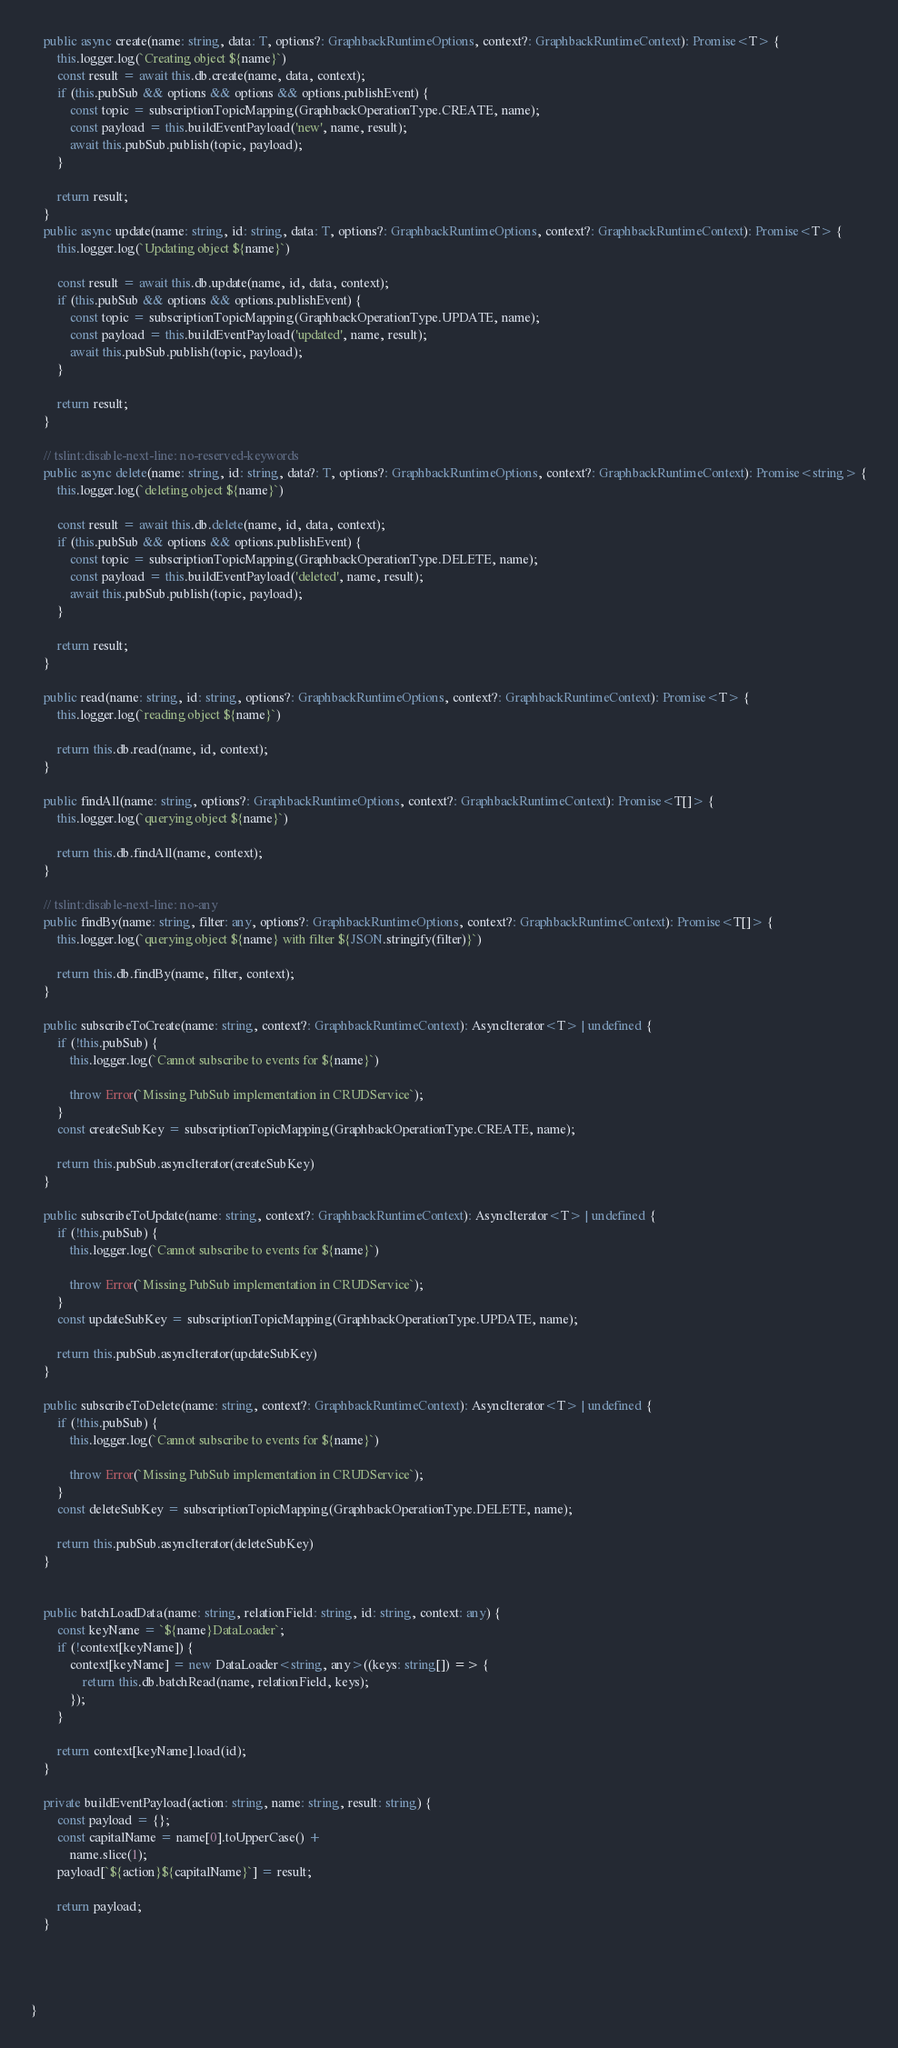<code> <loc_0><loc_0><loc_500><loc_500><_TypeScript_>    public async create(name: string, data: T, options?: GraphbackRuntimeOptions, context?: GraphbackRuntimeContext): Promise<T> {
        this.logger.log(`Creating object ${name}`)
        const result = await this.db.create(name, data, context);
        if (this.pubSub && options && options && options.publishEvent) {
            const topic = subscriptionTopicMapping(GraphbackOperationType.CREATE, name);
            const payload = this.buildEventPayload('new', name, result);
            await this.pubSub.publish(topic, payload);
        }

        return result;
    }
    public async update(name: string, id: string, data: T, options?: GraphbackRuntimeOptions, context?: GraphbackRuntimeContext): Promise<T> {
        this.logger.log(`Updating object ${name}`)

        const result = await this.db.update(name, id, data, context);
        if (this.pubSub && options && options.publishEvent) {
            const topic = subscriptionTopicMapping(GraphbackOperationType.UPDATE, name);
            const payload = this.buildEventPayload('updated', name, result);
            await this.pubSub.publish(topic, payload);
        }

        return result;
    }

    // tslint:disable-next-line: no-reserved-keywords
    public async delete(name: string, id: string, data?: T, options?: GraphbackRuntimeOptions, context?: GraphbackRuntimeContext): Promise<string> {
        this.logger.log(`deleting object ${name}`)

        const result = await this.db.delete(name, id, data, context);
        if (this.pubSub && options && options.publishEvent) {
            const topic = subscriptionTopicMapping(GraphbackOperationType.DELETE, name);
            const payload = this.buildEventPayload('deleted', name, result);
            await this.pubSub.publish(topic, payload);
        }

        return result;
    }

    public read(name: string, id: string, options?: GraphbackRuntimeOptions, context?: GraphbackRuntimeContext): Promise<T> {
        this.logger.log(`reading object ${name}`)

        return this.db.read(name, id, context);
    }

    public findAll(name: string, options?: GraphbackRuntimeOptions, context?: GraphbackRuntimeContext): Promise<T[]> {
        this.logger.log(`querying object ${name}`)

        return this.db.findAll(name, context);
    }

    // tslint:disable-next-line: no-any
    public findBy(name: string, filter: any, options?: GraphbackRuntimeOptions, context?: GraphbackRuntimeContext): Promise<T[]> {
        this.logger.log(`querying object ${name} with filter ${JSON.stringify(filter)}`)

        return this.db.findBy(name, filter, context);
    }

    public subscribeToCreate(name: string, context?: GraphbackRuntimeContext): AsyncIterator<T> | undefined {
        if (!this.pubSub) {
            this.logger.log(`Cannot subscribe to events for ${name}`)

            throw Error(`Missing PubSub implementation in CRUDService`);
        }
        const createSubKey = subscriptionTopicMapping(GraphbackOperationType.CREATE, name);

        return this.pubSub.asyncIterator(createSubKey)
    }

    public subscribeToUpdate(name: string, context?: GraphbackRuntimeContext): AsyncIterator<T> | undefined {
        if (!this.pubSub) {
            this.logger.log(`Cannot subscribe to events for ${name}`)

            throw Error(`Missing PubSub implementation in CRUDService`);
        }
        const updateSubKey = subscriptionTopicMapping(GraphbackOperationType.UPDATE, name);

        return this.pubSub.asyncIterator(updateSubKey)
    }

    public subscribeToDelete(name: string, context?: GraphbackRuntimeContext): AsyncIterator<T> | undefined {
        if (!this.pubSub) {
            this.logger.log(`Cannot subscribe to events for ${name}`)

            throw Error(`Missing PubSub implementation in CRUDService`);
        }
        const deleteSubKey = subscriptionTopicMapping(GraphbackOperationType.DELETE, name);

        return this.pubSub.asyncIterator(deleteSubKey)
    }

 
    public batchLoadData(name: string, relationField: string, id: string, context: any) {
        const keyName = `${name}DataLoader`;
        if (!context[keyName]) {
            context[keyName] = new DataLoader<string, any>((keys: string[]) => {
                return this.db.batchRead(name, relationField, keys);
            });
        }
     
        return context[keyName].load(id);
    }

    private buildEventPayload(action: string, name: string, result: string) {
        const payload = {};
        const capitalName = name[0].toUpperCase() +
            name.slice(1);
        payload[`${action}${capitalName}`] = result;

        return payload;
    }




}
</code> 